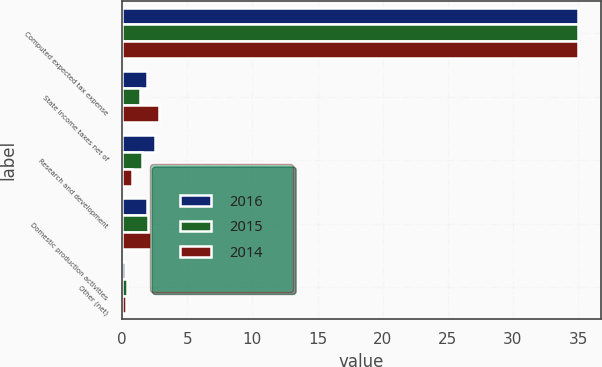<chart> <loc_0><loc_0><loc_500><loc_500><stacked_bar_chart><ecel><fcel>Computed expected tax expense<fcel>State income taxes net of<fcel>Research and development<fcel>Domestic production activities<fcel>Other (net)<nl><fcel>2016<fcel>35<fcel>1.9<fcel>2.5<fcel>1.9<fcel>0.2<nl><fcel>2015<fcel>35<fcel>1.4<fcel>1.5<fcel>2<fcel>0.4<nl><fcel>2014<fcel>35<fcel>2.8<fcel>0.8<fcel>2.2<fcel>0.3<nl></chart> 